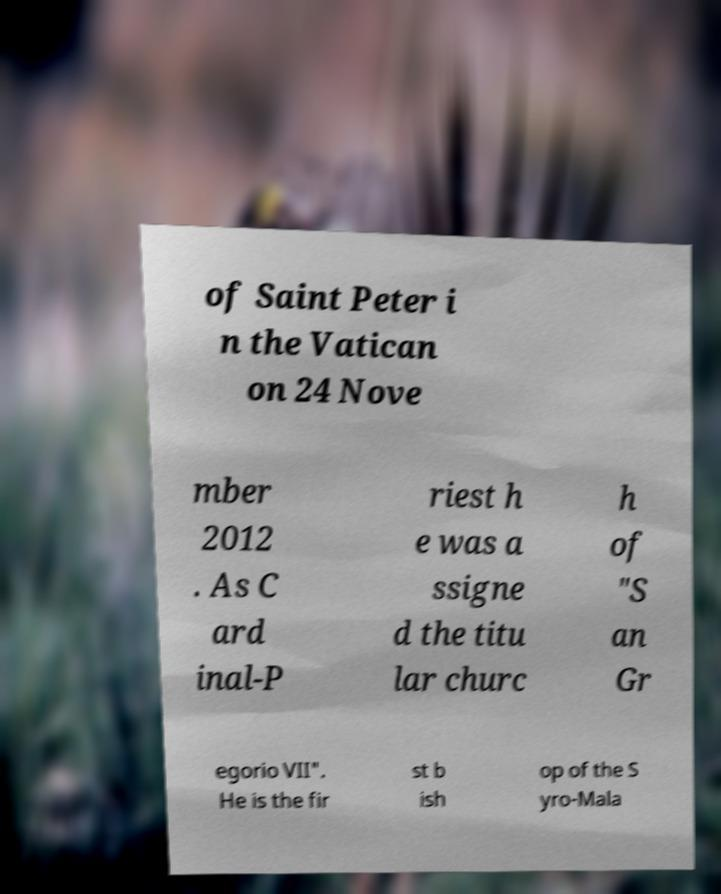Please identify and transcribe the text found in this image. of Saint Peter i n the Vatican on 24 Nove mber 2012 . As C ard inal-P riest h e was a ssigne d the titu lar churc h of "S an Gr egorio VII". He is the fir st b ish op of the S yro-Mala 